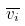<formula> <loc_0><loc_0><loc_500><loc_500>\overline { v _ { i } }</formula> 